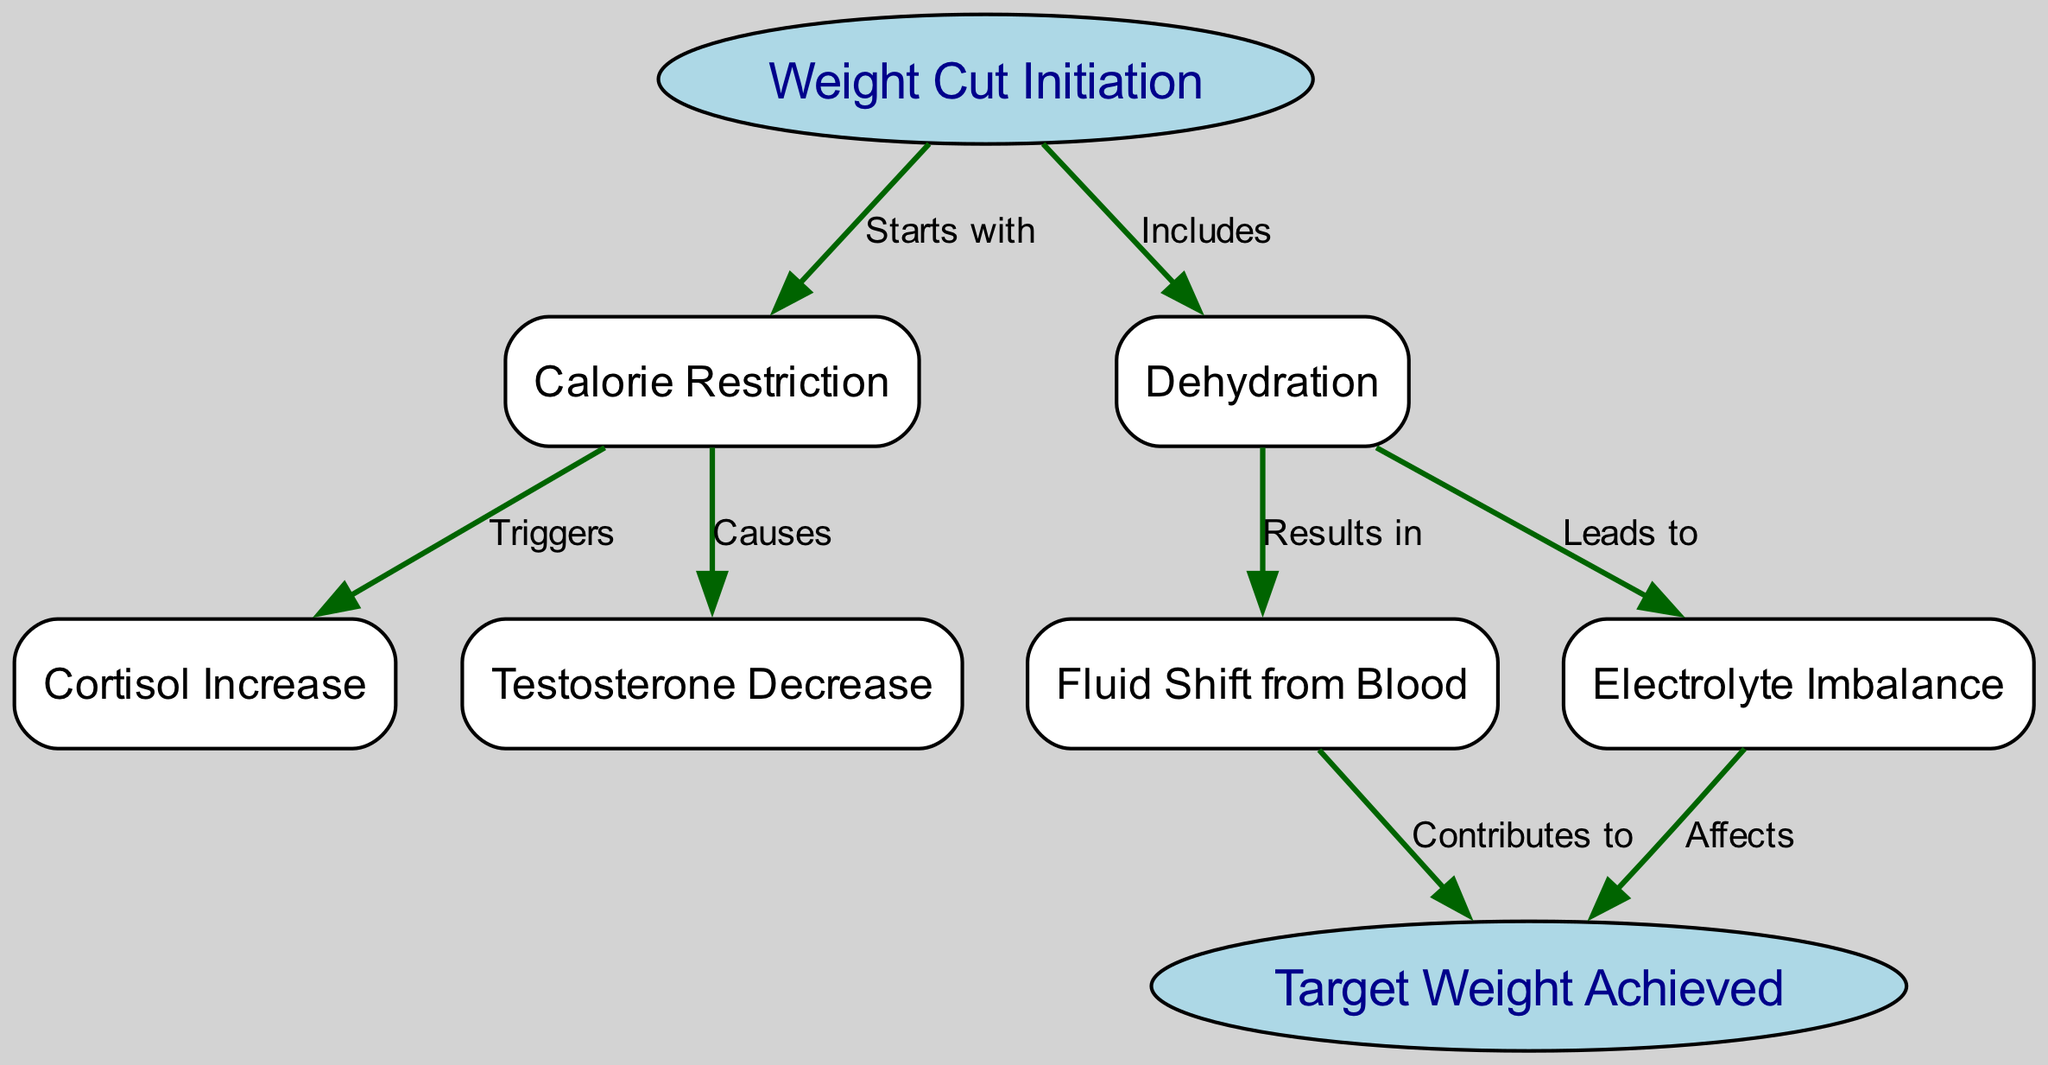What is the starting point of the weight cut process? The diagram indicates that the starting point is the "Weight Cut Initiation" node, which is labeled as the first node in the process.
Answer: Weight Cut Initiation What leads to electrolyte imbalance? According to the diagram, "Dehydration" leads to "Electrolyte Imbalance," as shown by the directed edge connecting these two nodes.
Answer: Dehydration How many nodes are present in this diagram? Counting the nodes listed in the diagram, there are a total of 8 nodes representing different stages in the weight cut process.
Answer: 8 What is the result of calorie restriction? The diagram shows that "Calorie Restriction" triggers an "Increase" in cortisol, indicating that this hormonal change is a direct result of reducing caloric intake.
Answer: Cortisol Increase What contributes to achieving target weight? The diagram specifies that "Fluid Shift from Blood" contributes to achieving "Target Weight," suggesting that this physiological change helps reach the desired weight.
Answer: Fluid Shift from Blood What two changes occur simultaneously after dehydration? The flow from "Dehydration" in the diagram indicates that it leads to both "Fluid Shift from Blood" and "Electrolyte Imbalance," meaning both of these conditions arise simultaneously.
Answer: Fluid Shift from Blood and Electrolyte Imbalance What does calorie restriction cause? The diagram indicates two outcomes from "Calorie Restriction": an increase in cortisol and a decrease in testosterone, both of which are hormonal changes resulting from this process.
Answer: Cortisol Increase and Testosterone Decrease 